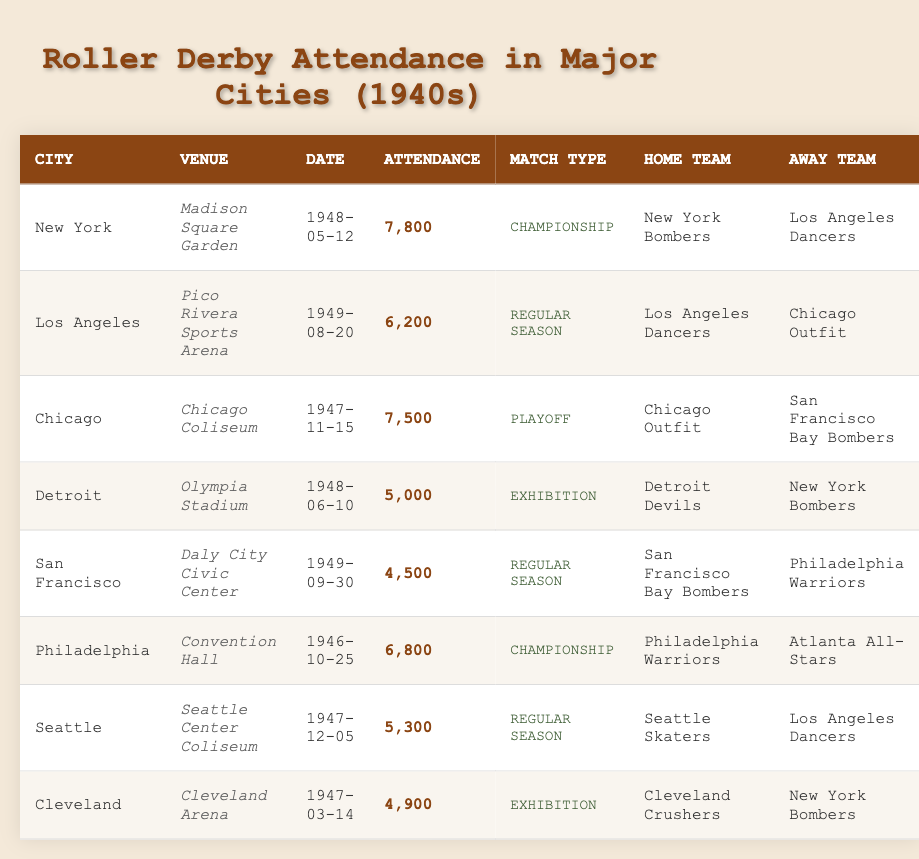What is the highest attendance recorded in the table? By reviewing the attendance figures listed for each match, the highest number is found in New York with 7,800 attendees on May 12, 1948.
Answer: 7,800 Which city hosted the fewest attendees during a regular season match? Checking the attendance numbers for regular season matches, the lowest occurs in San Francisco with 4,500 on September 30, 1949.
Answer: San Francisco How many Championship matches took place according to the table? The table lists two Championship matches: one in New York and one in Philadelphia, occurring on May 12, 1948, and October 25, 1946, respectively.
Answer: 2 In which city did the Chicago Outfit play as the home team? The table shows that the Chicago Outfit played as the home team in Chicago at the Chicago Coliseum on November 15, 1947.
Answer: Chicago What is the average attendance for the matches hosted in the city of Los Angeles? The attendance figures for Los Angeles are 6,200. This is a single match, so the average attendance is simply 6,200 divided by 1, which remains 6,200.
Answer: 6,200 Did more people attend the Detroit exhibition match or the San Francisco regular-season match? The attendance for the Detroit exhibition match is 5,000, while San Francisco’s regular season match recorded 4,500 attendees. Comparing the two, Detroit had more attendees.
Answer: Yes How many more attendees were at the New York Bombers match compared to the Cleveland Crushers match? New York's attendance was 7,800, while Cleveland's was 4,900. Subtracting the two figures gives 7,800 - 4,900 = 2,900 more attendees in New York.
Answer: 2,900 What percentage of the total attendance across all matches does the Chicago match's attendance represent? The total attendance across all matches in the table is 43,800. The Chicago match had 7,500 attendees. To find the percentage, divide 7,500 by 43,800 and multiply by 100: (7,500 / 43,800) * 100 ≈ 17.1%.
Answer: 17.1% Which city shows the greatest variety in match types? By examining the cities and their respective match types, Los Angeles and New York each hosted matches for Championship, Regular Season, and Playoff. Thus, both cities show a good variety, potentially more than others.
Answer: Los Angeles and New York What match had the highest attendance relative to the home team performance in the table? In this context, the highest attendance belongs to the New York Bombers at 7,800 during the Championship match, winning their home advantage at Madison Square Garden.
Answer: New York Bombers 